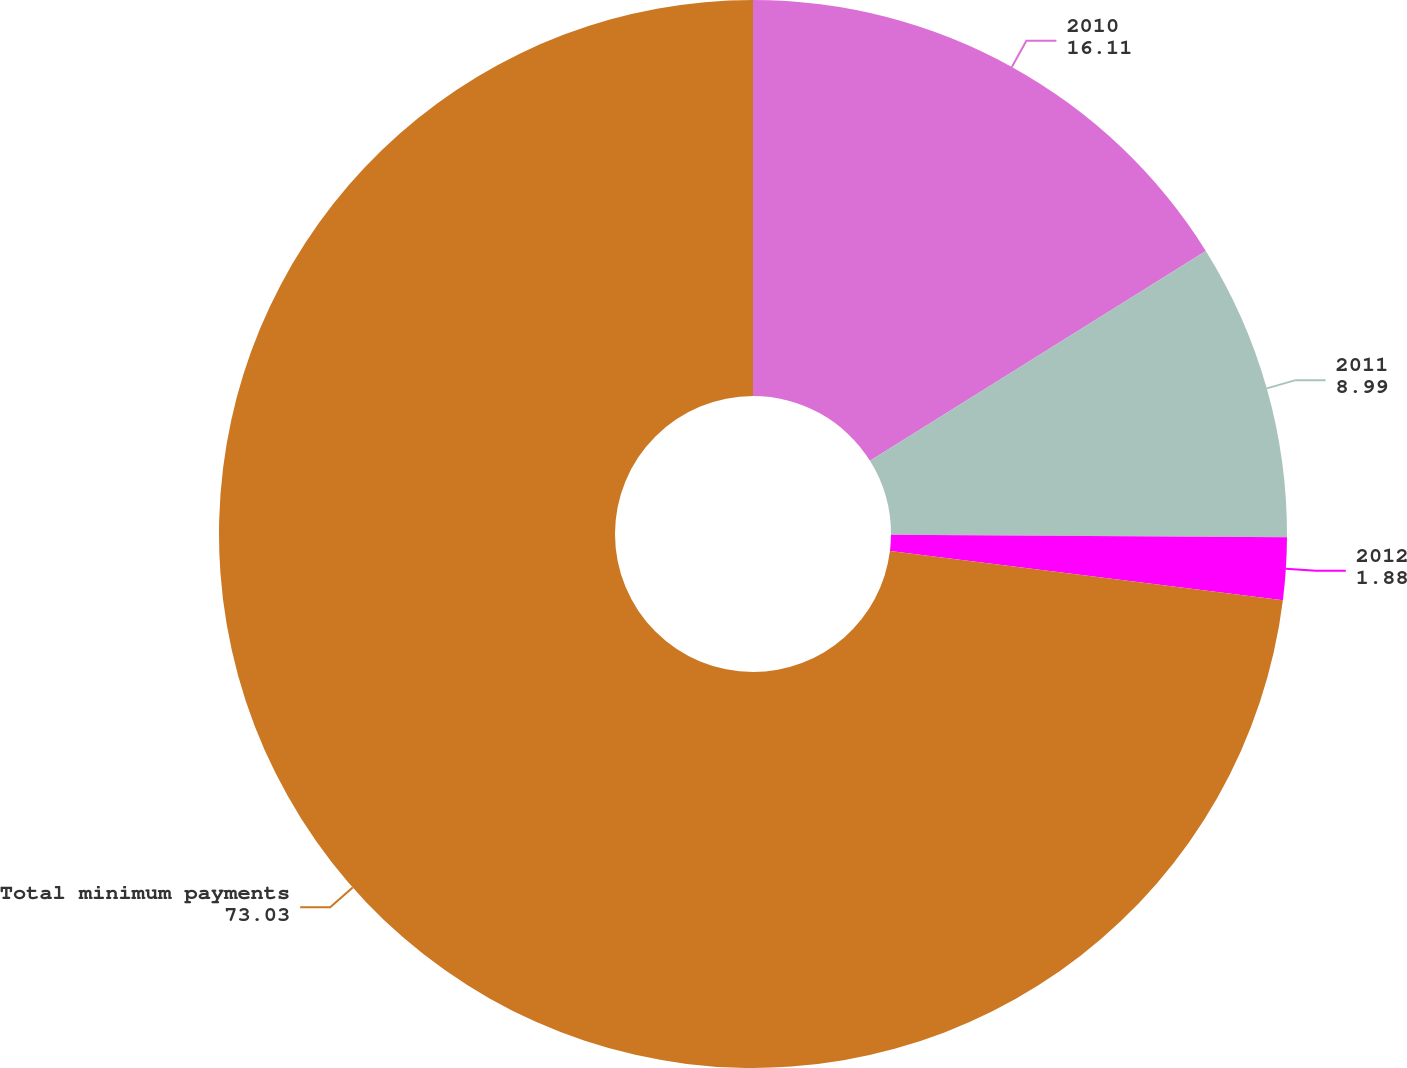<chart> <loc_0><loc_0><loc_500><loc_500><pie_chart><fcel>2010<fcel>2011<fcel>2012<fcel>Total minimum payments<nl><fcel>16.11%<fcel>8.99%<fcel>1.88%<fcel>73.03%<nl></chart> 